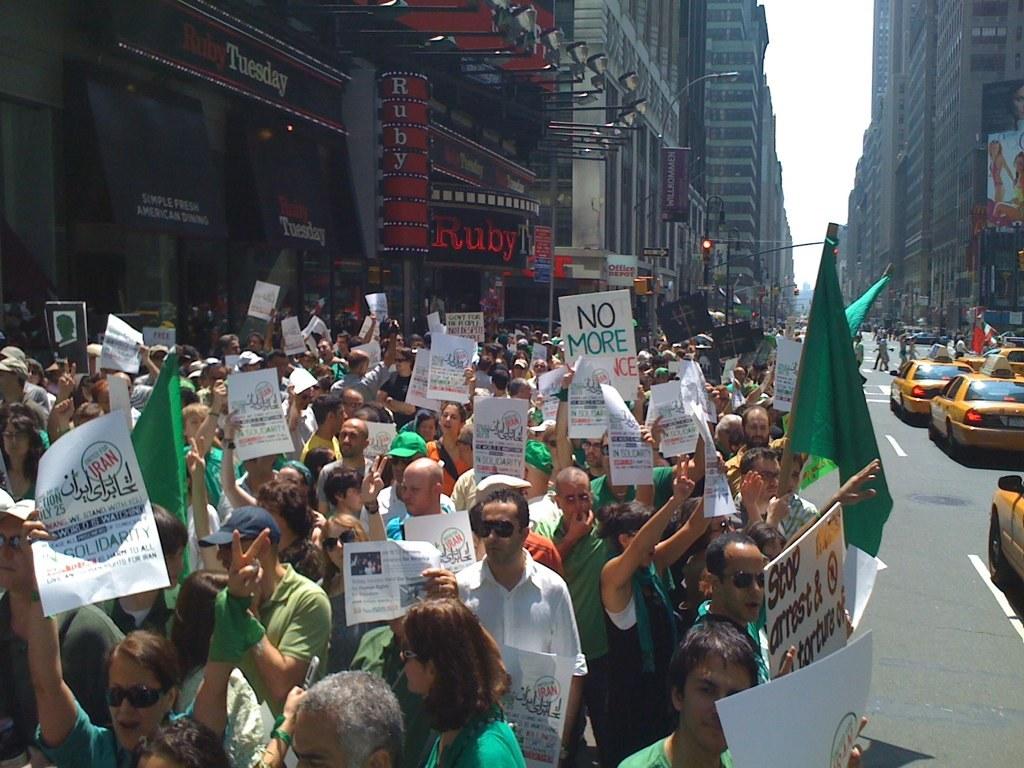What does one of the signs say to stop?
Provide a succinct answer. Amst. What restaurant are the protesters in front of?
Offer a very short reply. Ruby tuesday. 